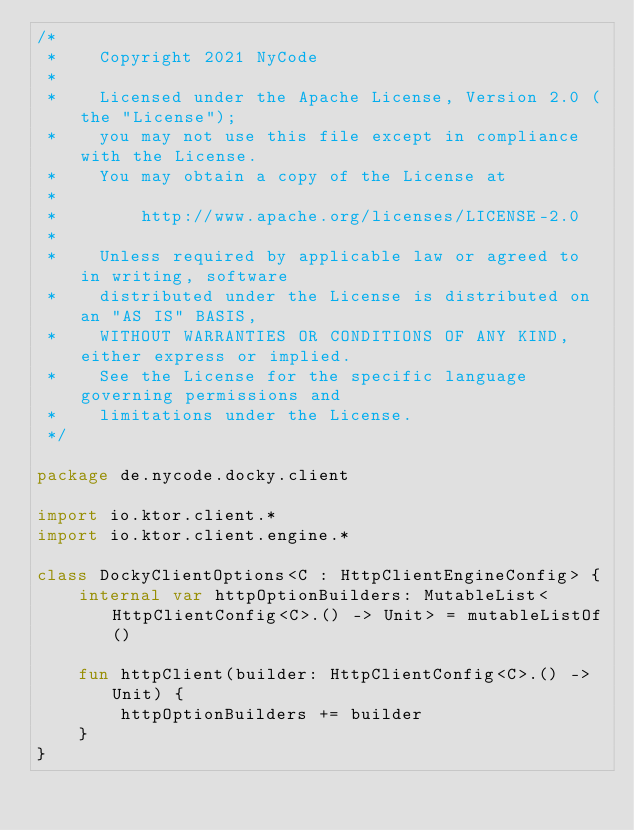<code> <loc_0><loc_0><loc_500><loc_500><_Kotlin_>/*
 *    Copyright 2021 NyCode
 *
 *    Licensed under the Apache License, Version 2.0 (the "License");
 *    you may not use this file except in compliance with the License.
 *    You may obtain a copy of the License at
 *
 *        http://www.apache.org/licenses/LICENSE-2.0
 *
 *    Unless required by applicable law or agreed to in writing, software
 *    distributed under the License is distributed on an "AS IS" BASIS,
 *    WITHOUT WARRANTIES OR CONDITIONS OF ANY KIND, either express or implied.
 *    See the License for the specific language governing permissions and
 *    limitations under the License.
 */

package de.nycode.docky.client

import io.ktor.client.*
import io.ktor.client.engine.*

class DockyClientOptions<C : HttpClientEngineConfig> {
    internal var httpOptionBuilders: MutableList<HttpClientConfig<C>.() -> Unit> = mutableListOf()

    fun httpClient(builder: HttpClientConfig<C>.() -> Unit) {
        httpOptionBuilders += builder
    }
}
</code> 